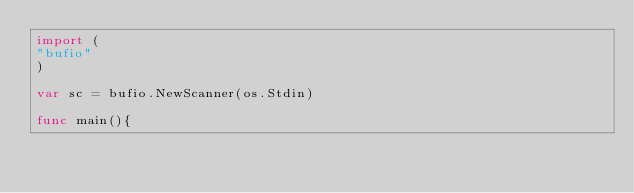<code> <loc_0><loc_0><loc_500><loc_500><_Go_>import (
"bufio"
)

var sc = bufio.NewScanner(os.Stdin)

func main(){
      </code> 